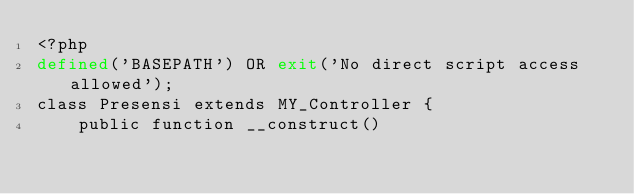Convert code to text. <code><loc_0><loc_0><loc_500><loc_500><_PHP_><?php
defined('BASEPATH') OR exit('No direct script access allowed');
class Presensi extends MY_Controller {
    public function __construct()</code> 